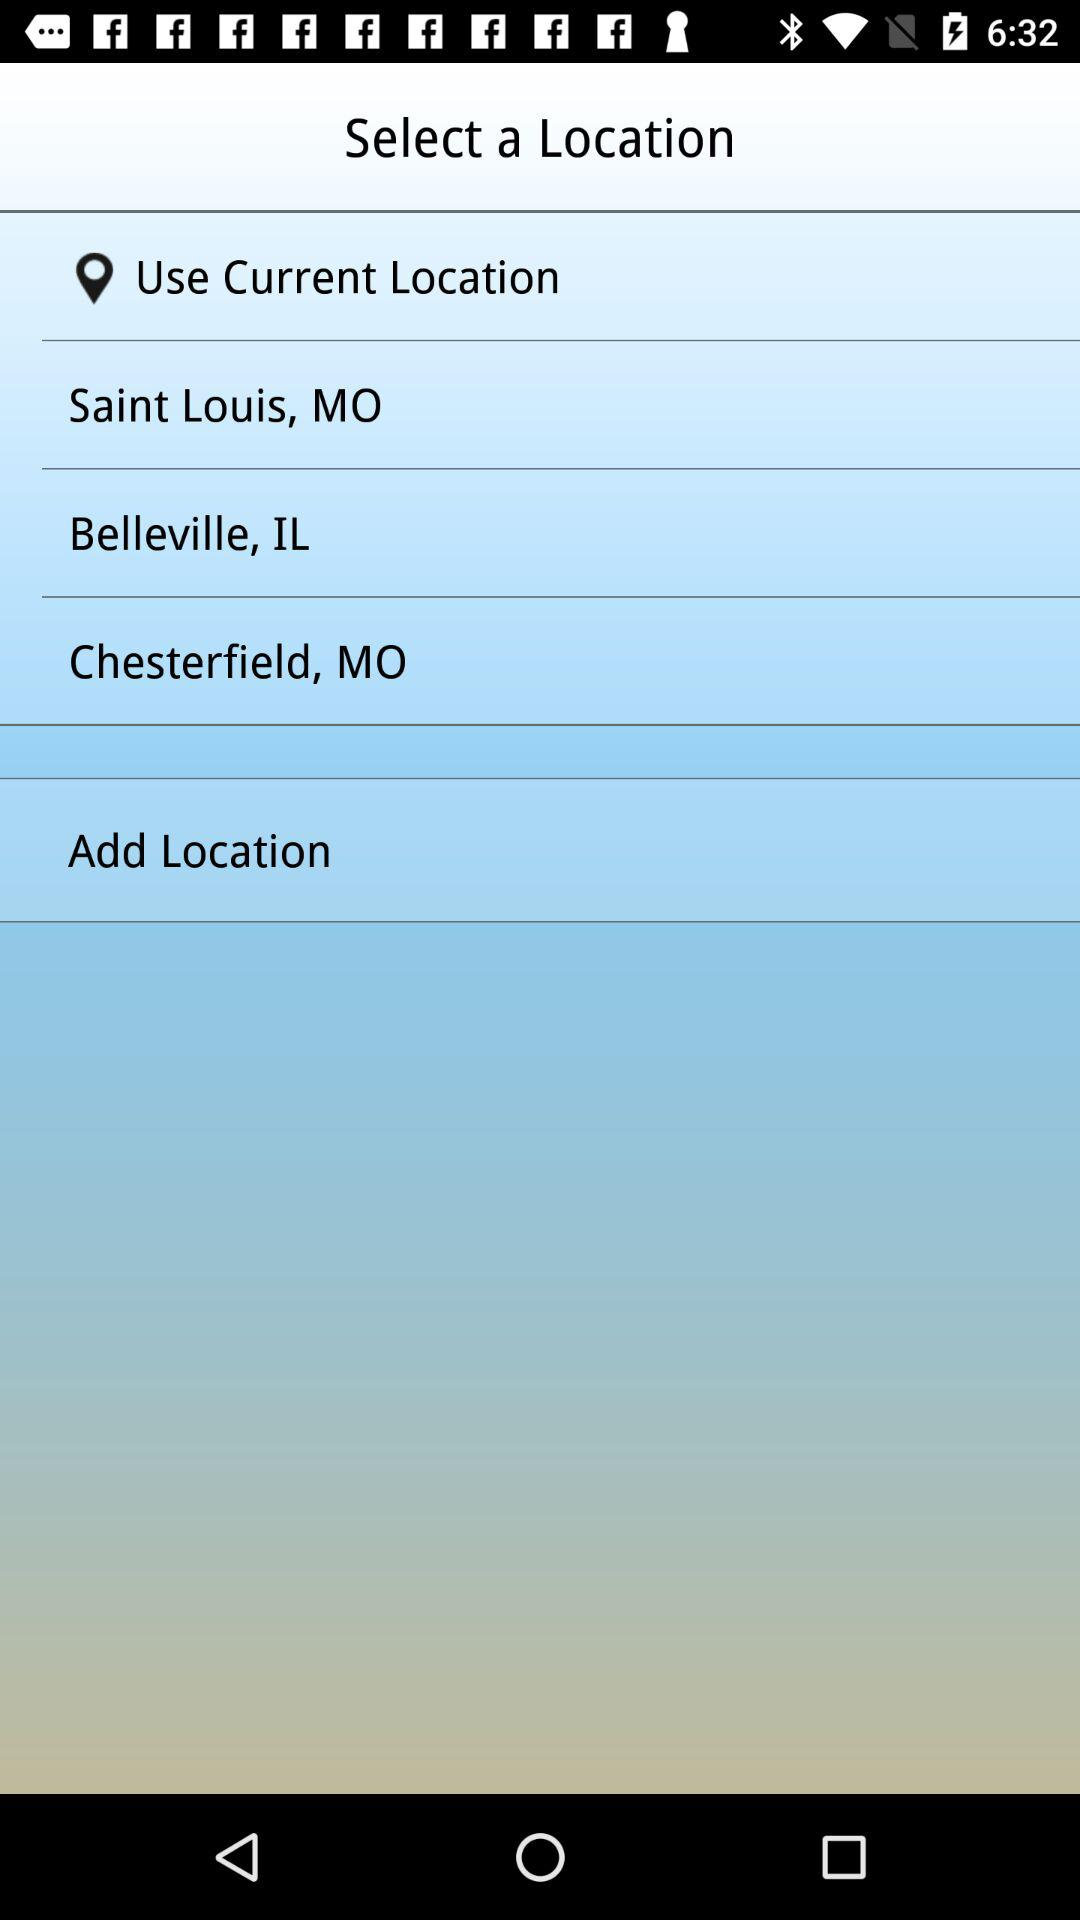How many locations are available for selection?
Answer the question using a single word or phrase. 4 